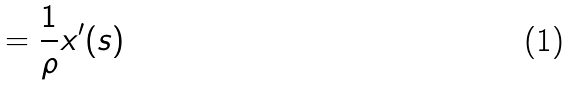Convert formula to latex. <formula><loc_0><loc_0><loc_500><loc_500>= \frac { 1 } { \rho } x ^ { \prime } ( s )</formula> 